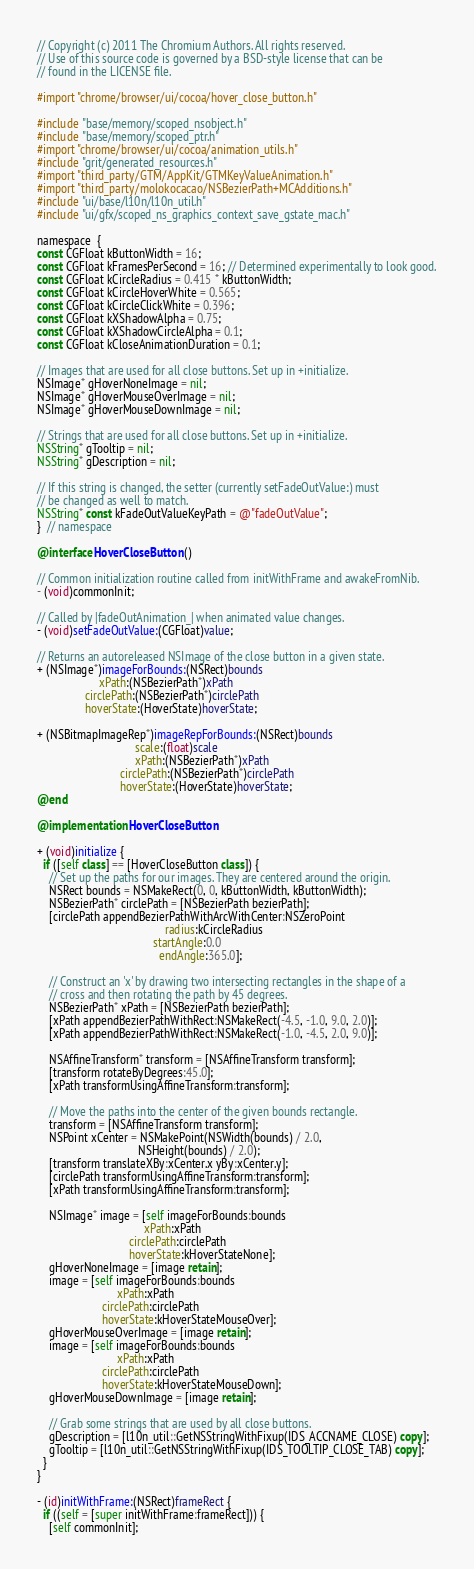Convert code to text. <code><loc_0><loc_0><loc_500><loc_500><_ObjectiveC_>// Copyright (c) 2011 The Chromium Authors. All rights reserved.
// Use of this source code is governed by a BSD-style license that can be
// found in the LICENSE file.

#import "chrome/browser/ui/cocoa/hover_close_button.h"

#include "base/memory/scoped_nsobject.h"
#include "base/memory/scoped_ptr.h"
#import "chrome/browser/ui/cocoa/animation_utils.h"
#include "grit/generated_resources.h"
#import "third_party/GTM/AppKit/GTMKeyValueAnimation.h"
#import "third_party/molokocacao/NSBezierPath+MCAdditions.h"
#include "ui/base/l10n/l10n_util.h"
#include "ui/gfx/scoped_ns_graphics_context_save_gstate_mac.h"

namespace  {
const CGFloat kButtonWidth = 16;
const CGFloat kFramesPerSecond = 16; // Determined experimentally to look good.
const CGFloat kCircleRadius = 0.415 * kButtonWidth;
const CGFloat kCircleHoverWhite = 0.565;
const CGFloat kCircleClickWhite = 0.396;
const CGFloat kXShadowAlpha = 0.75;
const CGFloat kXShadowCircleAlpha = 0.1;
const CGFloat kCloseAnimationDuration = 0.1;

// Images that are used for all close buttons. Set up in +initialize.
NSImage* gHoverNoneImage = nil;
NSImage* gHoverMouseOverImage = nil;
NSImage* gHoverMouseDownImage = nil;

// Strings that are used for all close buttons. Set up in +initialize.
NSString* gTooltip = nil;
NSString* gDescription = nil;

// If this string is changed, the setter (currently setFadeOutValue:) must
// be changed as well to match.
NSString* const kFadeOutValueKeyPath = @"fadeOutValue";
}  // namespace

@interface HoverCloseButton ()

// Common initialization routine called from initWithFrame and awakeFromNib.
- (void)commonInit;

// Called by |fadeOutAnimation_| when animated value changes.
- (void)setFadeOutValue:(CGFloat)value;

// Returns an autoreleased NSImage of the close button in a given state.
+ (NSImage*)imageForBounds:(NSRect)bounds
                     xPath:(NSBezierPath*)xPath
                circlePath:(NSBezierPath*)circlePath
                hoverState:(HoverState)hoverState;

+ (NSBitmapImageRep*)imageRepForBounds:(NSRect)bounds
                                 scale:(float)scale
                                 xPath:(NSBezierPath*)xPath
                            circlePath:(NSBezierPath*)circlePath
                            hoverState:(HoverState)hoverState;
@end

@implementation HoverCloseButton

+ (void)initialize {
  if ([self class] == [HoverCloseButton class]) {
    // Set up the paths for our images. They are centered around the origin.
    NSRect bounds = NSMakeRect(0, 0, kButtonWidth, kButtonWidth);
    NSBezierPath* circlePath = [NSBezierPath bezierPath];
    [circlePath appendBezierPathWithArcWithCenter:NSZeroPoint
                                           radius:kCircleRadius
                                       startAngle:0.0
                                         endAngle:365.0];

    // Construct an 'x' by drawing two intersecting rectangles in the shape of a
    // cross and then rotating the path by 45 degrees.
    NSBezierPath* xPath = [NSBezierPath bezierPath];
    [xPath appendBezierPathWithRect:NSMakeRect(-4.5, -1.0, 9.0, 2.0)];
    [xPath appendBezierPathWithRect:NSMakeRect(-1.0, -4.5, 2.0, 9.0)];

    NSAffineTransform* transform = [NSAffineTransform transform];
    [transform rotateByDegrees:45.0];
    [xPath transformUsingAffineTransform:transform];

    // Move the paths into the center of the given bounds rectangle.
    transform = [NSAffineTransform transform];
    NSPoint xCenter = NSMakePoint(NSWidth(bounds) / 2.0,
                                  NSHeight(bounds) / 2.0);
    [transform translateXBy:xCenter.x yBy:xCenter.y];
    [circlePath transformUsingAffineTransform:transform];
    [xPath transformUsingAffineTransform:transform];

    NSImage* image = [self imageForBounds:bounds
                                    xPath:xPath
                               circlePath:circlePath
                               hoverState:kHoverStateNone];
    gHoverNoneImage = [image retain];
    image = [self imageForBounds:bounds
                           xPath:xPath
                      circlePath:circlePath
                      hoverState:kHoverStateMouseOver];
    gHoverMouseOverImage = [image retain];
    image = [self imageForBounds:bounds
                           xPath:xPath
                      circlePath:circlePath
                      hoverState:kHoverStateMouseDown];
    gHoverMouseDownImage = [image retain];

    // Grab some strings that are used by all close buttons.
    gDescription = [l10n_util::GetNSStringWithFixup(IDS_ACCNAME_CLOSE) copy];
    gTooltip = [l10n_util::GetNSStringWithFixup(IDS_TOOLTIP_CLOSE_TAB) copy];
  }
}

- (id)initWithFrame:(NSRect)frameRect {
  if ((self = [super initWithFrame:frameRect])) {
    [self commonInit];</code> 